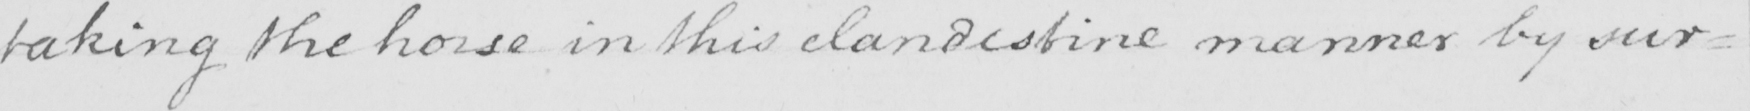Please transcribe the handwritten text in this image. taking the horse in this clandestine manner by sur= 